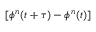<formula> <loc_0><loc_0><loc_500><loc_500>[ \phi ^ { n } ( t + \tau ) - \phi ^ { n } ( t ) ]</formula> 